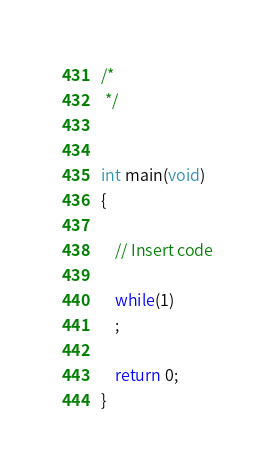<code> <loc_0><loc_0><loc_500><loc_500><_C_>/*
 */


int main(void)
{

    // Insert code

    while(1)
    ;

    return 0;
}
</code> 